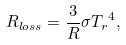<formula> <loc_0><loc_0><loc_500><loc_500>R _ { l o s s } = \frac { 3 } { R } \sigma { T _ { r } } ^ { 4 } ,</formula> 